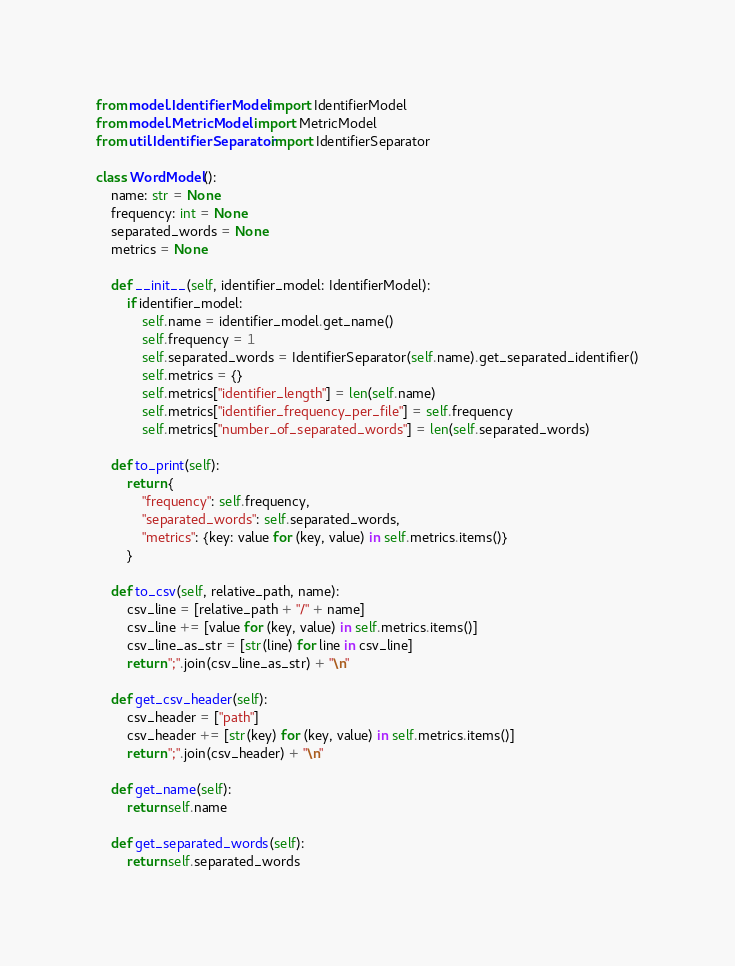<code> <loc_0><loc_0><loc_500><loc_500><_Python_>from model.IdentifierModel import IdentifierModel
from model.MetricModel import MetricModel
from util.IdentifierSeparator import IdentifierSeparator

class WordModel():
    name: str = None
    frequency: int = None
    separated_words = None
    metrics = None

    def __init__(self, identifier_model: IdentifierModel):
        if identifier_model:
            self.name = identifier_model.get_name()
            self.frequency = 1
            self.separated_words = IdentifierSeparator(self.name).get_separated_identifier()
            self.metrics = {}
            self.metrics["identifier_length"] = len(self.name)
            self.metrics["identifier_frequency_per_file"] = self.frequency
            self.metrics["number_of_separated_words"] = len(self.separated_words)

    def to_print(self):
        return {
            "frequency": self.frequency,
            "separated_words": self.separated_words,
            "metrics": {key: value for (key, value) in self.metrics.items()}
        }

    def to_csv(self, relative_path, name):
        csv_line = [relative_path + "/" + name]
        csv_line += [value for (key, value) in self.metrics.items()]
        csv_line_as_str = [str(line) for line in csv_line]
        return ";".join(csv_line_as_str) + "\n"

    def get_csv_header(self):
        csv_header = ["path"] 
        csv_header += [str(key) for (key, value) in self.metrics.items()]
        return ";".join(csv_header) + "\n"

    def get_name(self):
        return self.name
        
    def get_separated_words(self):
        return self.separated_words
</code> 